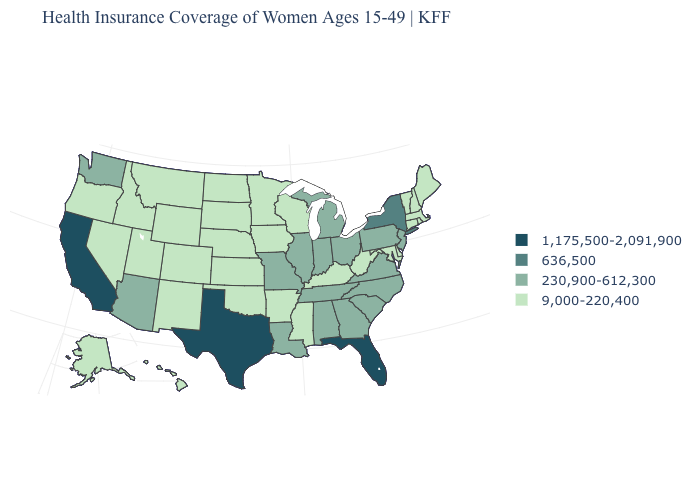What is the value of Massachusetts?
Quick response, please. 9,000-220,400. Is the legend a continuous bar?
Concise answer only. No. Among the states that border Minnesota , which have the lowest value?
Write a very short answer. Iowa, North Dakota, South Dakota, Wisconsin. Name the states that have a value in the range 1,175,500-2,091,900?
Give a very brief answer. California, Florida, Texas. Name the states that have a value in the range 636,500?
Keep it brief. New York. Does Iowa have the lowest value in the MidWest?
Concise answer only. Yes. Among the states that border Virginia , does North Carolina have the highest value?
Write a very short answer. Yes. What is the value of Texas?
Answer briefly. 1,175,500-2,091,900. What is the lowest value in the USA?
Keep it brief. 9,000-220,400. Name the states that have a value in the range 230,900-612,300?
Short answer required. Alabama, Arizona, Georgia, Illinois, Indiana, Louisiana, Michigan, Missouri, New Jersey, North Carolina, Ohio, Pennsylvania, South Carolina, Tennessee, Virginia, Washington. What is the value of Colorado?
Be succinct. 9,000-220,400. Among the states that border Connecticut , which have the lowest value?
Answer briefly. Massachusetts, Rhode Island. Does the map have missing data?
Quick response, please. No. Name the states that have a value in the range 9,000-220,400?
Concise answer only. Alaska, Arkansas, Colorado, Connecticut, Delaware, Hawaii, Idaho, Iowa, Kansas, Kentucky, Maine, Maryland, Massachusetts, Minnesota, Mississippi, Montana, Nebraska, Nevada, New Hampshire, New Mexico, North Dakota, Oklahoma, Oregon, Rhode Island, South Dakota, Utah, Vermont, West Virginia, Wisconsin, Wyoming. Name the states that have a value in the range 230,900-612,300?
Write a very short answer. Alabama, Arizona, Georgia, Illinois, Indiana, Louisiana, Michigan, Missouri, New Jersey, North Carolina, Ohio, Pennsylvania, South Carolina, Tennessee, Virginia, Washington. 